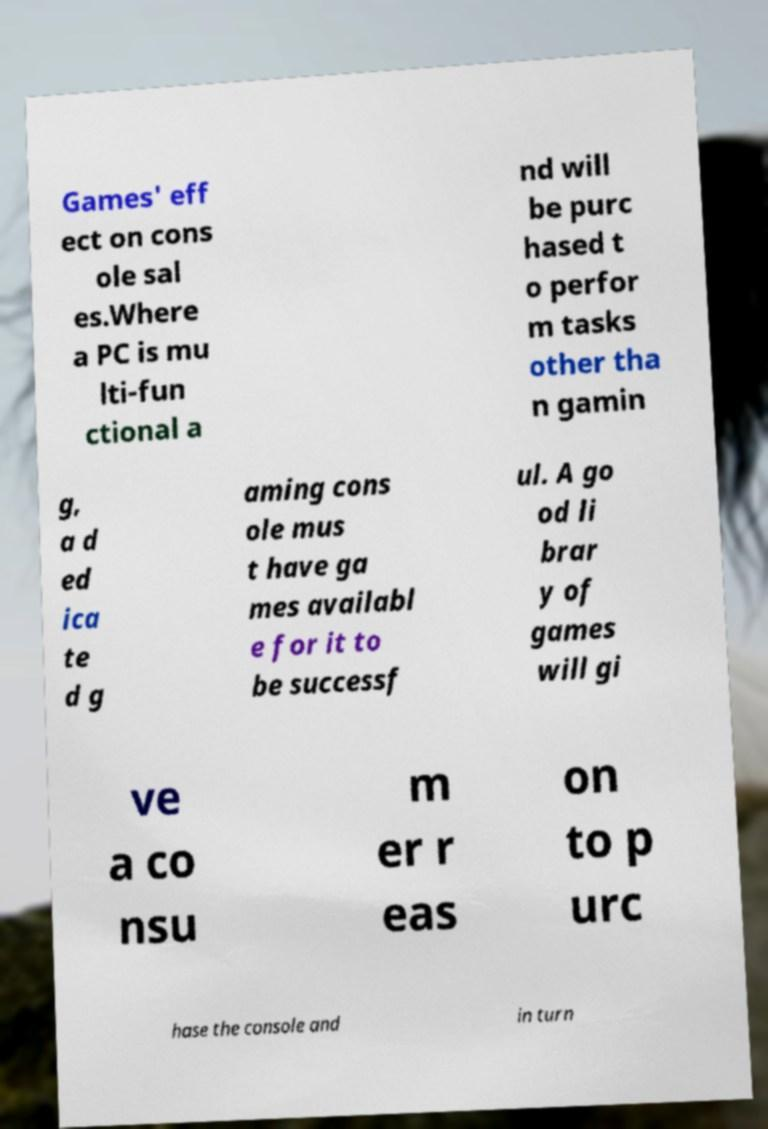I need the written content from this picture converted into text. Can you do that? Games' eff ect on cons ole sal es.Where a PC is mu lti-fun ctional a nd will be purc hased t o perfor m tasks other tha n gamin g, a d ed ica te d g aming cons ole mus t have ga mes availabl e for it to be successf ul. A go od li brar y of games will gi ve a co nsu m er r eas on to p urc hase the console and in turn 